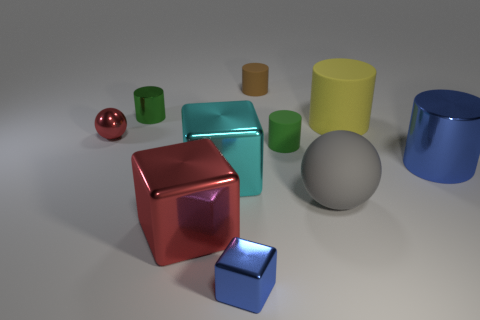What sort of atmosphere or mood does the lighting in this image create? The lighting in the image creates a calm and neutral atmosphere. It's soft and diffused, providing even illumination without harsh shadows or bright spots, which contributes to an overall serene and balanced visual mood. 